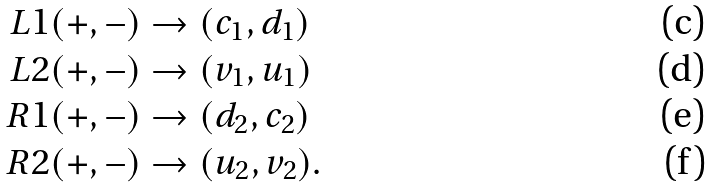<formula> <loc_0><loc_0><loc_500><loc_500>L 1 ( + , - ) & \rightarrow ( c _ { 1 } , d _ { 1 } ) \\ L 2 ( + , - ) & \rightarrow ( v _ { 1 } , u _ { 1 } ) \\ R 1 ( + , - ) & \rightarrow ( d _ { 2 } , c _ { 2 } ) \\ R 2 ( + , - ) & \rightarrow ( u _ { 2 } , v _ { 2 } ) .</formula> 